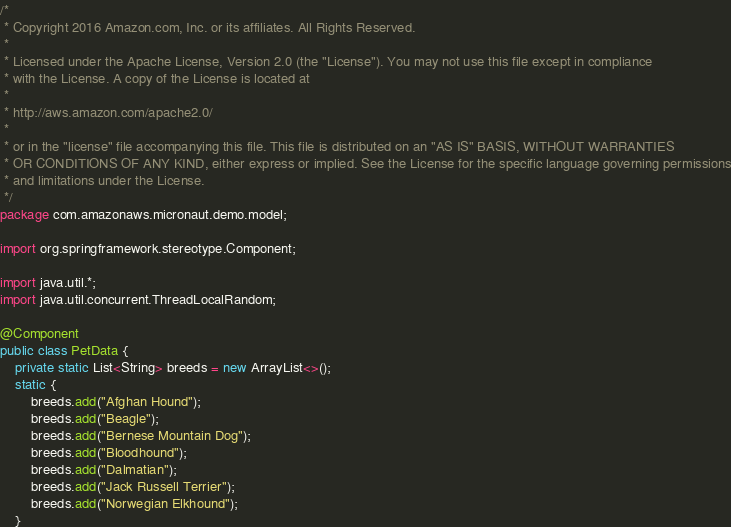Convert code to text. <code><loc_0><loc_0><loc_500><loc_500><_Java_>/*
 * Copyright 2016 Amazon.com, Inc. or its affiliates. All Rights Reserved.
 *
 * Licensed under the Apache License, Version 2.0 (the "License"). You may not use this file except in compliance
 * with the License. A copy of the License is located at
 *
 * http://aws.amazon.com/apache2.0/
 *
 * or in the "license" file accompanying this file. This file is distributed on an "AS IS" BASIS, WITHOUT WARRANTIES
 * OR CONDITIONS OF ANY KIND, either express or implied. See the License for the specific language governing permissions
 * and limitations under the License.
 */
package com.amazonaws.micronaut.demo.model;

import org.springframework.stereotype.Component;

import java.util.*;
import java.util.concurrent.ThreadLocalRandom;

@Component
public class PetData {
    private static List<String> breeds = new ArrayList<>();
    static {
        breeds.add("Afghan Hound");
        breeds.add("Beagle");
        breeds.add("Bernese Mountain Dog");
        breeds.add("Bloodhound");
        breeds.add("Dalmatian");
        breeds.add("Jack Russell Terrier");
        breeds.add("Norwegian Elkhound");
    }
</code> 